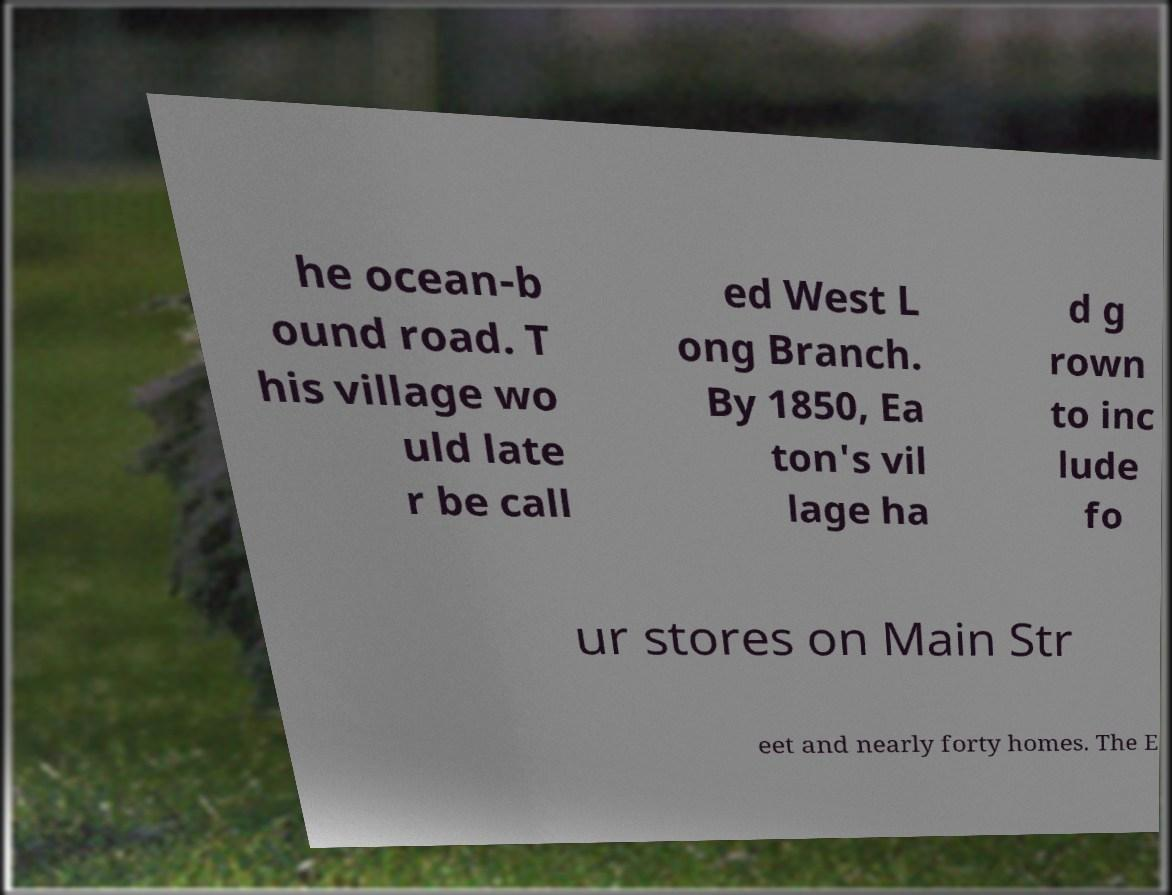Please read and relay the text visible in this image. What does it say? he ocean-b ound road. T his village wo uld late r be call ed West L ong Branch. By 1850, Ea ton's vil lage ha d g rown to inc lude fo ur stores on Main Str eet and nearly forty homes. The E 